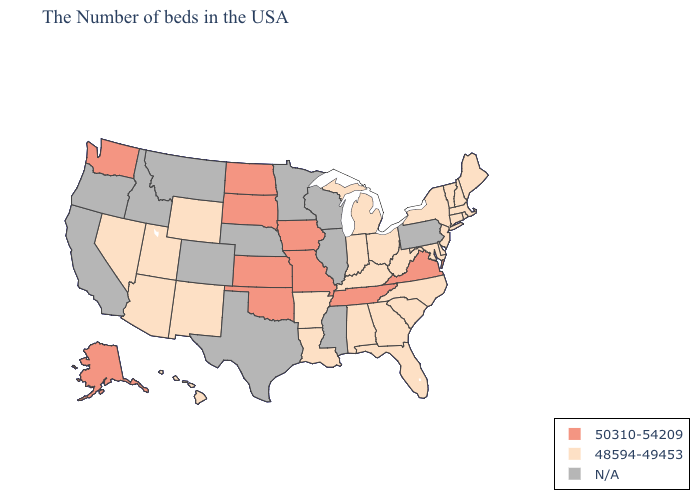Which states have the lowest value in the South?
Keep it brief. Delaware, Maryland, North Carolina, South Carolina, West Virginia, Florida, Georgia, Kentucky, Alabama, Louisiana, Arkansas. Name the states that have a value in the range 50310-54209?
Be succinct. Virginia, Tennessee, Missouri, Iowa, Kansas, Oklahoma, South Dakota, North Dakota, Washington, Alaska. Name the states that have a value in the range N/A?
Quick response, please. Pennsylvania, Wisconsin, Illinois, Mississippi, Minnesota, Nebraska, Texas, Colorado, Montana, Idaho, California, Oregon. What is the lowest value in the South?
Keep it brief. 48594-49453. What is the highest value in states that border Massachusetts?
Short answer required. 48594-49453. Does Ohio have the lowest value in the MidWest?
Answer briefly. Yes. Which states have the lowest value in the USA?
Short answer required. Maine, Massachusetts, Rhode Island, New Hampshire, Vermont, Connecticut, New York, New Jersey, Delaware, Maryland, North Carolina, South Carolina, West Virginia, Ohio, Florida, Georgia, Michigan, Kentucky, Indiana, Alabama, Louisiana, Arkansas, Wyoming, New Mexico, Utah, Arizona, Nevada, Hawaii. Which states have the lowest value in the Northeast?
Short answer required. Maine, Massachusetts, Rhode Island, New Hampshire, Vermont, Connecticut, New York, New Jersey. What is the value of Arkansas?
Answer briefly. 48594-49453. Name the states that have a value in the range 50310-54209?
Be succinct. Virginia, Tennessee, Missouri, Iowa, Kansas, Oklahoma, South Dakota, North Dakota, Washington, Alaska. What is the value of Louisiana?
Short answer required. 48594-49453. Among the states that border Virginia , does Tennessee have the lowest value?
Write a very short answer. No. Does the map have missing data?
Give a very brief answer. Yes. What is the value of Alabama?
Keep it brief. 48594-49453. 